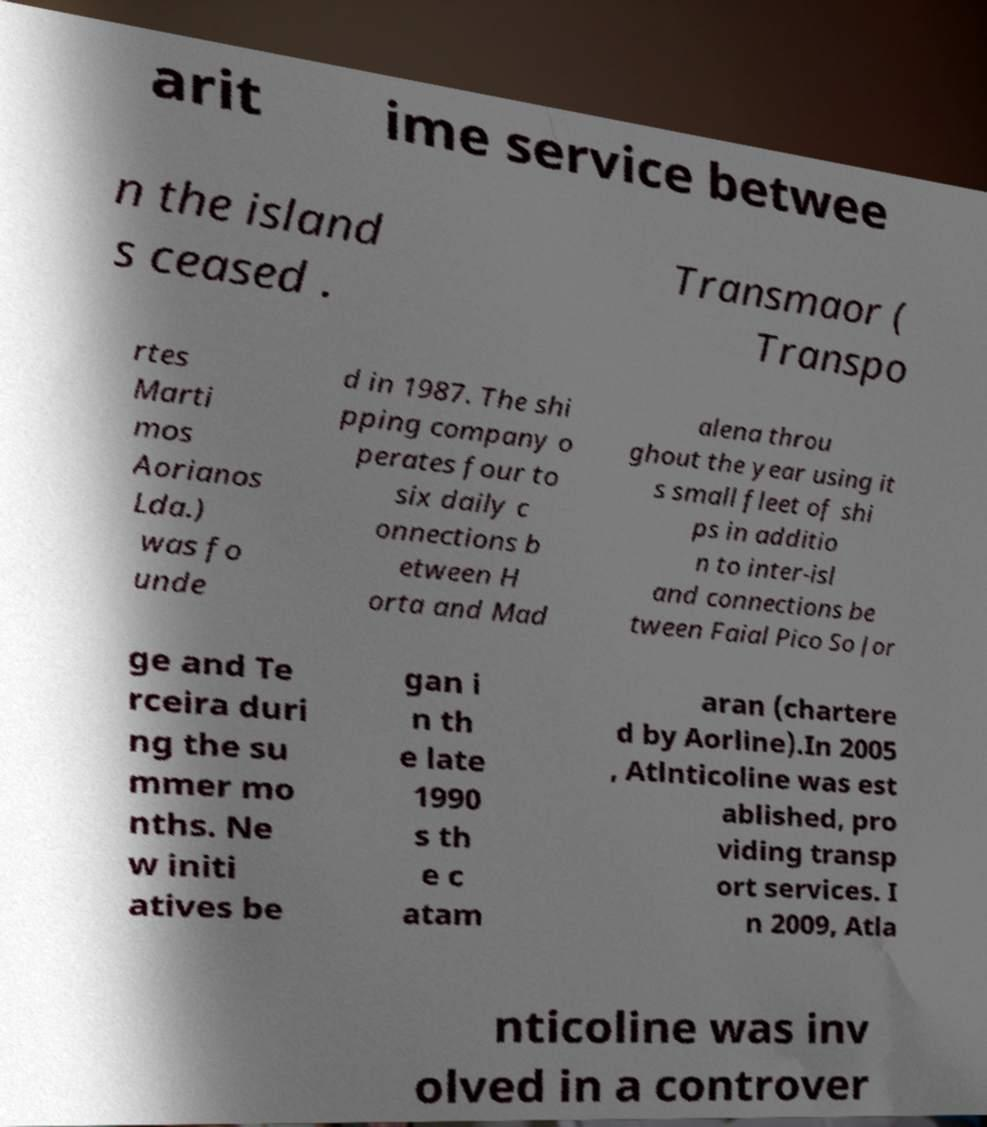There's text embedded in this image that I need extracted. Can you transcribe it verbatim? arit ime service betwee n the island s ceased . Transmaor ( Transpo rtes Marti mos Aorianos Lda.) was fo unde d in 1987. The shi pping company o perates four to six daily c onnections b etween H orta and Mad alena throu ghout the year using it s small fleet of shi ps in additio n to inter-isl and connections be tween Faial Pico So Jor ge and Te rceira duri ng the su mmer mo nths. Ne w initi atives be gan i n th e late 1990 s th e c atam aran (chartere d by Aorline).In 2005 , Atlnticoline was est ablished, pro viding transp ort services. I n 2009, Atla nticoline was inv olved in a controver 